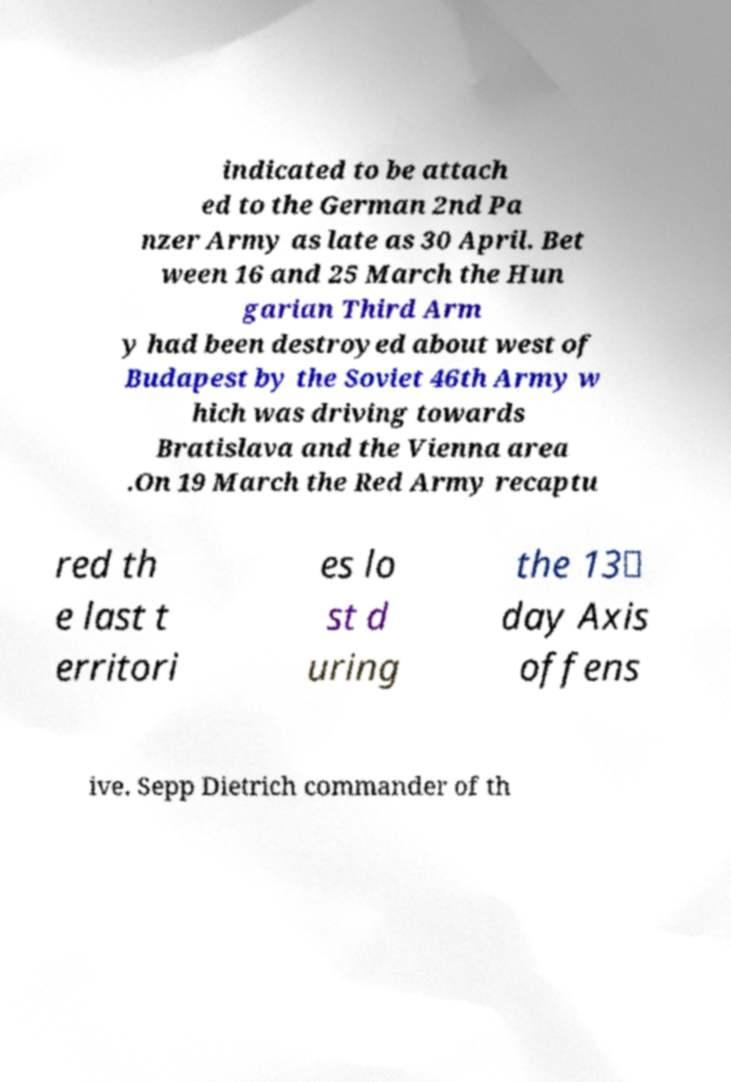I need the written content from this picture converted into text. Can you do that? indicated to be attach ed to the German 2nd Pa nzer Army as late as 30 April. Bet ween 16 and 25 March the Hun garian Third Arm y had been destroyed about west of Budapest by the Soviet 46th Army w hich was driving towards Bratislava and the Vienna area .On 19 March the Red Army recaptu red th e last t erritori es lo st d uring the 13‑ day Axis offens ive. Sepp Dietrich commander of th 